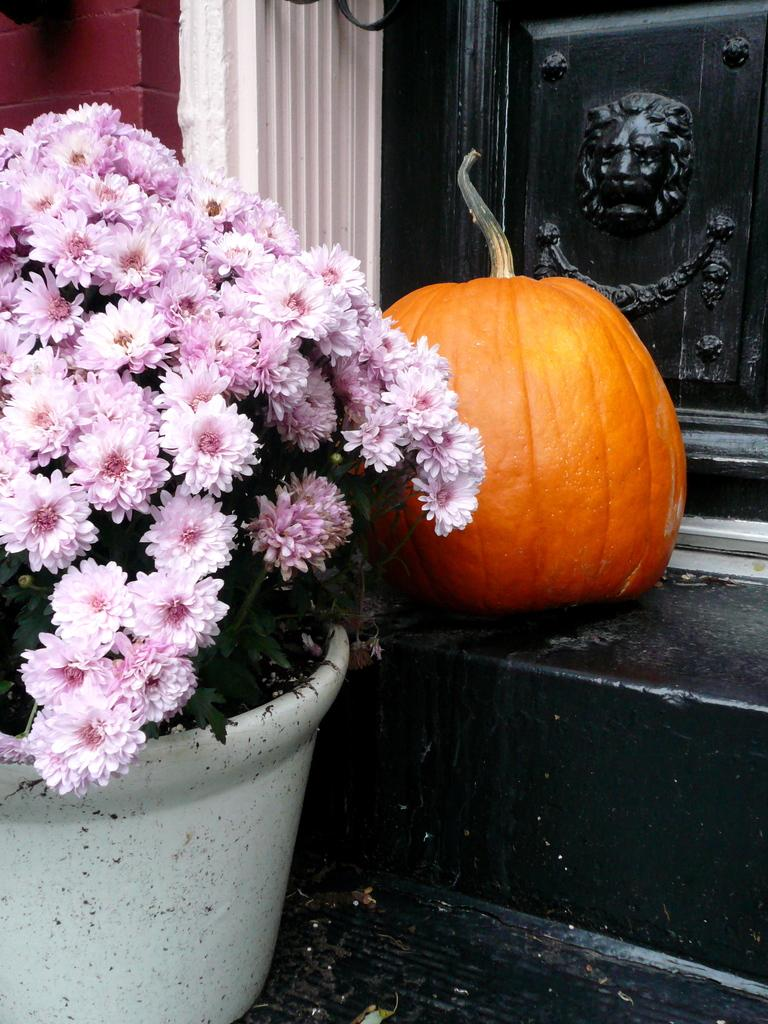What type of structure can be seen in the image? There is a wall with a door in the image. Are there any architectural features visible in the image? Yes, there are stairs in the image. What can be found on the stairs? There is a plant with flowers in a pot and a pumpkin on the stairs. What type of ring can be seen on the plant in the image? There is no ring present in the image; it features a plant with flowers in a pot and a pumpkin on the stairs. Can you describe the worm crawling on the pumpkin in the image? There is no worm present in the image; it only shows a plant with flowers in a pot and a pumpkin on the stairs. 